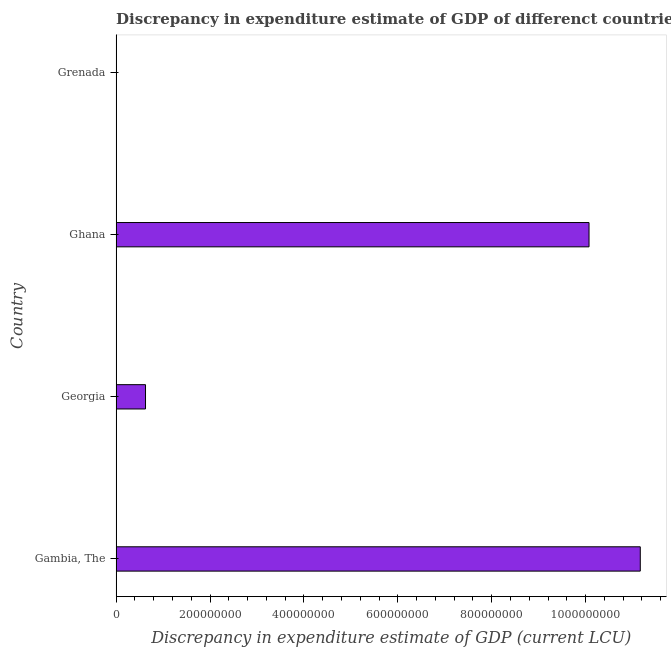Does the graph contain any zero values?
Your answer should be compact. No. What is the title of the graph?
Your answer should be very brief. Discrepancy in expenditure estimate of GDP of differenct countries in 2010. What is the label or title of the X-axis?
Keep it short and to the point. Discrepancy in expenditure estimate of GDP (current LCU). What is the discrepancy in expenditure estimate of gdp in Gambia, The?
Make the answer very short. 1.12e+09. Across all countries, what is the maximum discrepancy in expenditure estimate of gdp?
Make the answer very short. 1.12e+09. Across all countries, what is the minimum discrepancy in expenditure estimate of gdp?
Offer a very short reply. 3e-7. In which country was the discrepancy in expenditure estimate of gdp maximum?
Ensure brevity in your answer.  Gambia, The. In which country was the discrepancy in expenditure estimate of gdp minimum?
Provide a short and direct response. Grenada. What is the sum of the discrepancy in expenditure estimate of gdp?
Your response must be concise. 2.19e+09. What is the difference between the discrepancy in expenditure estimate of gdp in Gambia, The and Grenada?
Offer a terse response. 1.12e+09. What is the average discrepancy in expenditure estimate of gdp per country?
Your answer should be very brief. 5.47e+08. What is the median discrepancy in expenditure estimate of gdp?
Keep it short and to the point. 5.35e+08. What is the ratio of the discrepancy in expenditure estimate of gdp in Ghana to that in Grenada?
Keep it short and to the point. 3.36e+15. Is the discrepancy in expenditure estimate of gdp in Georgia less than that in Ghana?
Your answer should be compact. Yes. What is the difference between the highest and the second highest discrepancy in expenditure estimate of gdp?
Provide a succinct answer. 1.09e+08. Is the sum of the discrepancy in expenditure estimate of gdp in Georgia and Grenada greater than the maximum discrepancy in expenditure estimate of gdp across all countries?
Give a very brief answer. No. What is the difference between the highest and the lowest discrepancy in expenditure estimate of gdp?
Provide a succinct answer. 1.12e+09. How many bars are there?
Keep it short and to the point. 4. What is the Discrepancy in expenditure estimate of GDP (current LCU) of Gambia, The?
Give a very brief answer. 1.12e+09. What is the Discrepancy in expenditure estimate of GDP (current LCU) in Georgia?
Your answer should be compact. 6.26e+07. What is the Discrepancy in expenditure estimate of GDP (current LCU) in Ghana?
Give a very brief answer. 1.01e+09. What is the Discrepancy in expenditure estimate of GDP (current LCU) in Grenada?
Keep it short and to the point. 3e-7. What is the difference between the Discrepancy in expenditure estimate of GDP (current LCU) in Gambia, The and Georgia?
Your answer should be compact. 1.05e+09. What is the difference between the Discrepancy in expenditure estimate of GDP (current LCU) in Gambia, The and Ghana?
Keep it short and to the point. 1.09e+08. What is the difference between the Discrepancy in expenditure estimate of GDP (current LCU) in Gambia, The and Grenada?
Ensure brevity in your answer.  1.12e+09. What is the difference between the Discrepancy in expenditure estimate of GDP (current LCU) in Georgia and Ghana?
Your answer should be compact. -9.45e+08. What is the difference between the Discrepancy in expenditure estimate of GDP (current LCU) in Georgia and Grenada?
Provide a short and direct response. 6.26e+07. What is the difference between the Discrepancy in expenditure estimate of GDP (current LCU) in Ghana and Grenada?
Your answer should be very brief. 1.01e+09. What is the ratio of the Discrepancy in expenditure estimate of GDP (current LCU) in Gambia, The to that in Georgia?
Provide a short and direct response. 17.84. What is the ratio of the Discrepancy in expenditure estimate of GDP (current LCU) in Gambia, The to that in Ghana?
Give a very brief answer. 1.11. What is the ratio of the Discrepancy in expenditure estimate of GDP (current LCU) in Gambia, The to that in Grenada?
Provide a succinct answer. 3.72e+15. What is the ratio of the Discrepancy in expenditure estimate of GDP (current LCU) in Georgia to that in Ghana?
Your answer should be very brief. 0.06. What is the ratio of the Discrepancy in expenditure estimate of GDP (current LCU) in Georgia to that in Grenada?
Your answer should be very brief. 2.09e+14. What is the ratio of the Discrepancy in expenditure estimate of GDP (current LCU) in Ghana to that in Grenada?
Offer a terse response. 3.36e+15. 